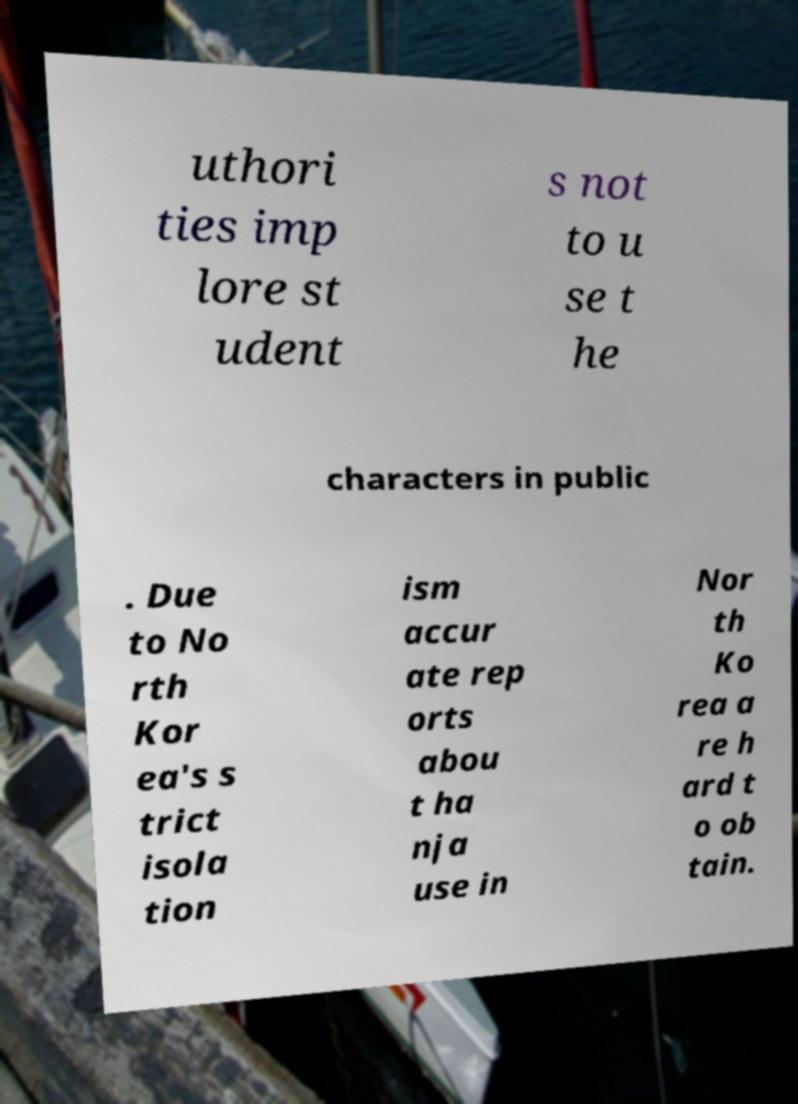Please read and relay the text visible in this image. What does it say? uthori ties imp lore st udent s not to u se t he characters in public . Due to No rth Kor ea's s trict isola tion ism accur ate rep orts abou t ha nja use in Nor th Ko rea a re h ard t o ob tain. 